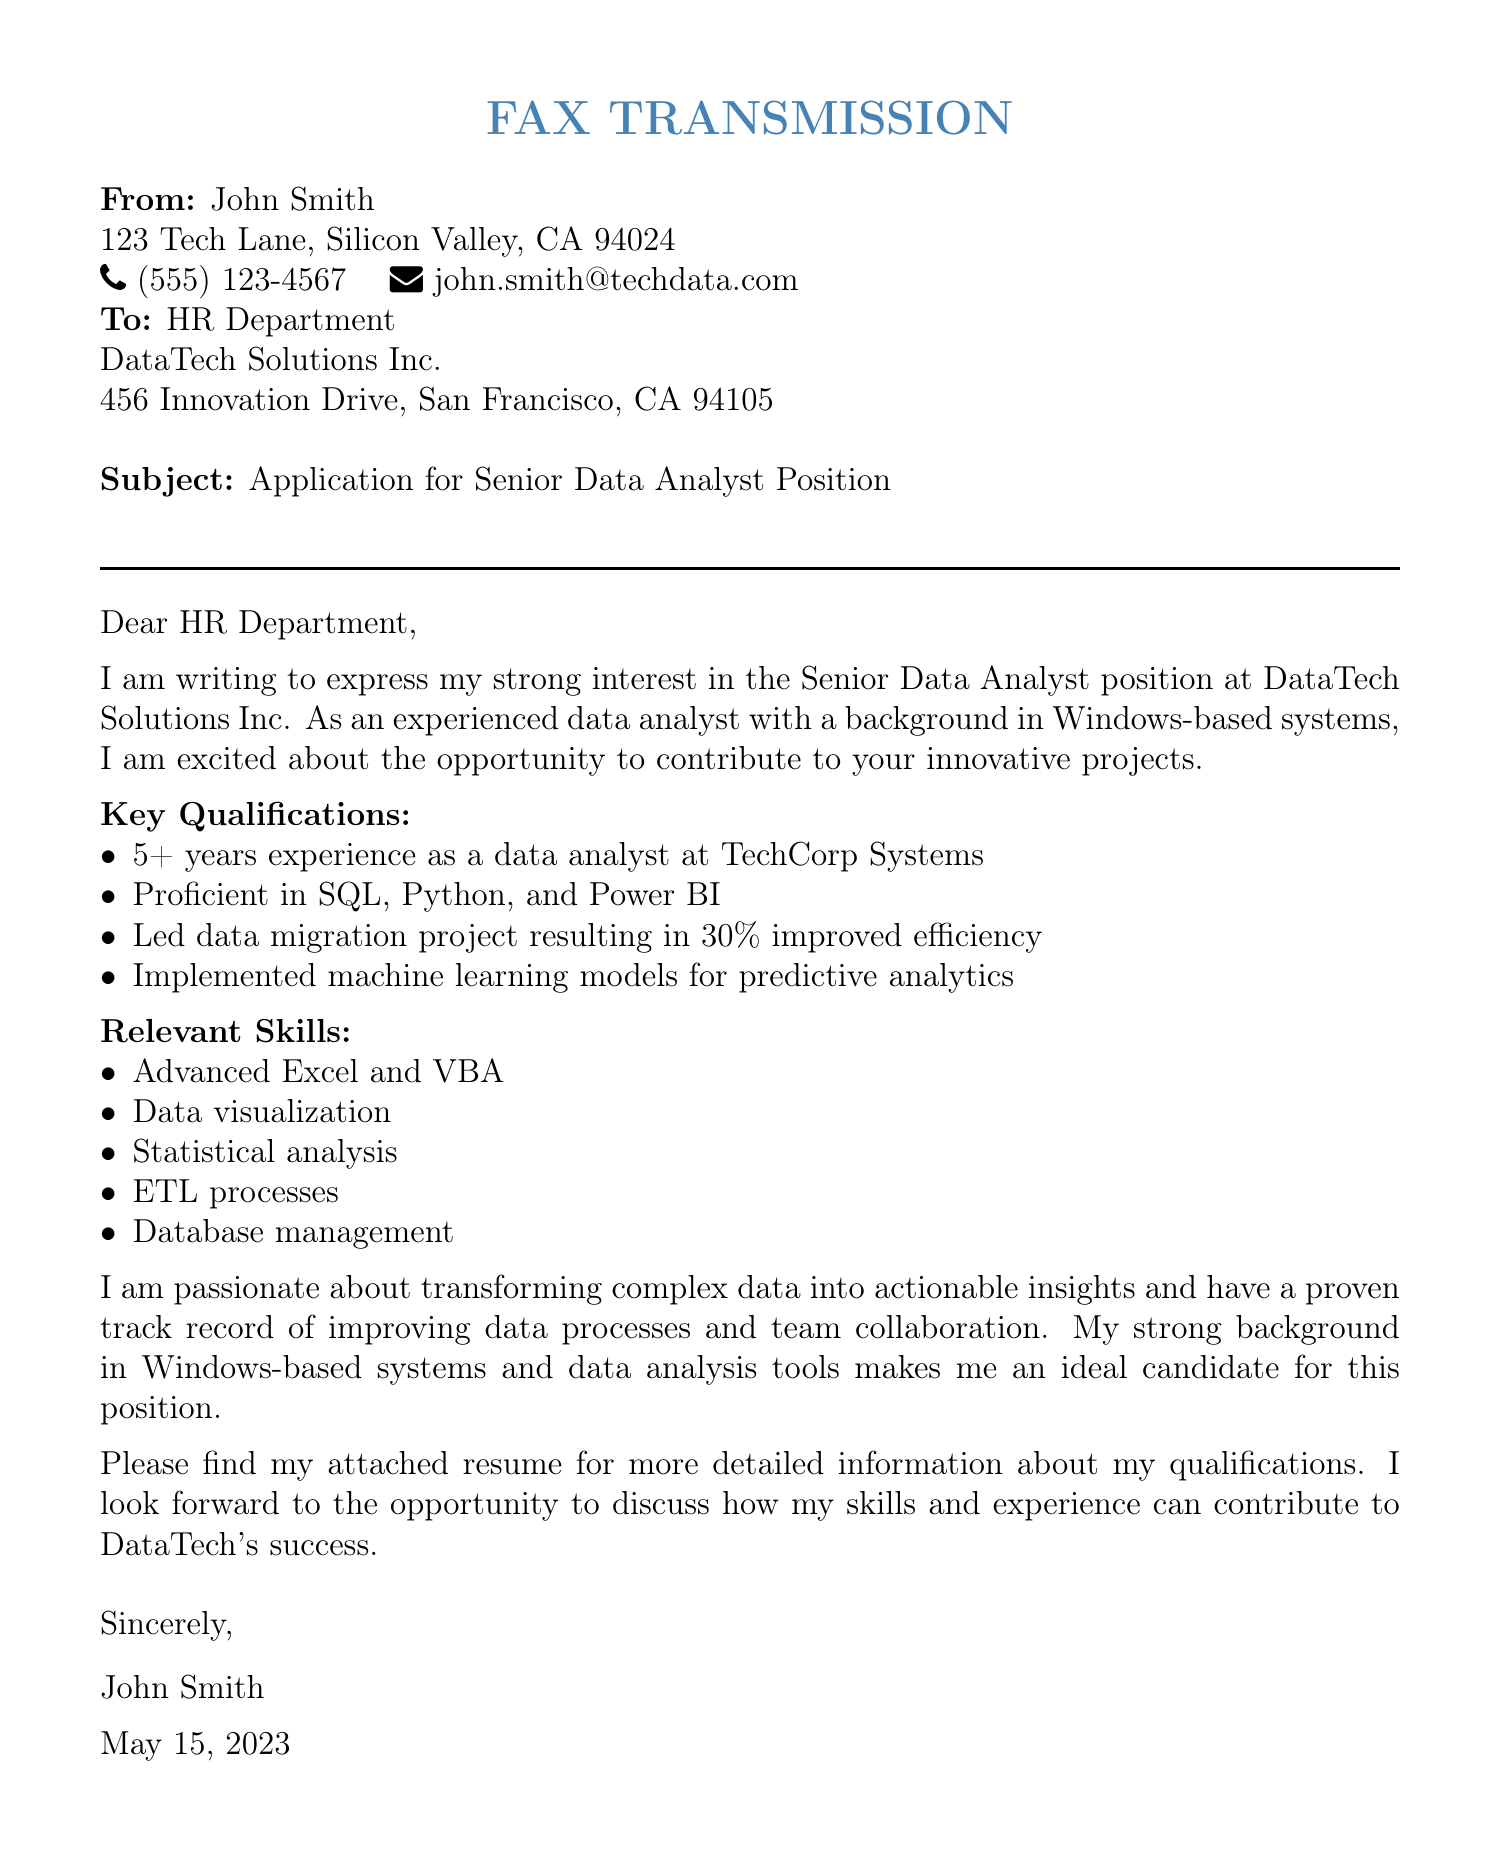What is the sender's name? The sender's name is stated at the beginning of the fax document as John Smith.
Answer: John Smith What is the recipient's company name? The company name of the recipient is indicated in the fax as DataTech Solutions Inc.
Answer: DataTech Solutions Inc What is the subject of the fax? The subject line clearly states "Application for Senior Data Analyst Position."
Answer: Application for Senior Data Analyst Position How many years of experience does the sender have? The sender mentions having "5+ years experience as a data analyst."
Answer: 5+ What programming languages is the sender proficient in? The fax lists "SQL, Python, and Power BI" as the sender's proficient programming languages.
Answer: SQL, Python, and Power BI What project resulted in improved efficiency? The sender states that they "led data migration project resulting in 30% improved efficiency."
Answer: data migration project When was this fax sent? The date is clearly written at the end of the fax as May 15, 2023.
Answer: May 15, 2023 What is one of the sender's relevant skills? The document lists "Advanced Excel and VBA" as one of the relevant skills.
Answer: Advanced Excel and VBA What does the sender express passion for? The sender expresses a passion for "transforming complex data into actionable insights."
Answer: transforming complex data into actionable insights 